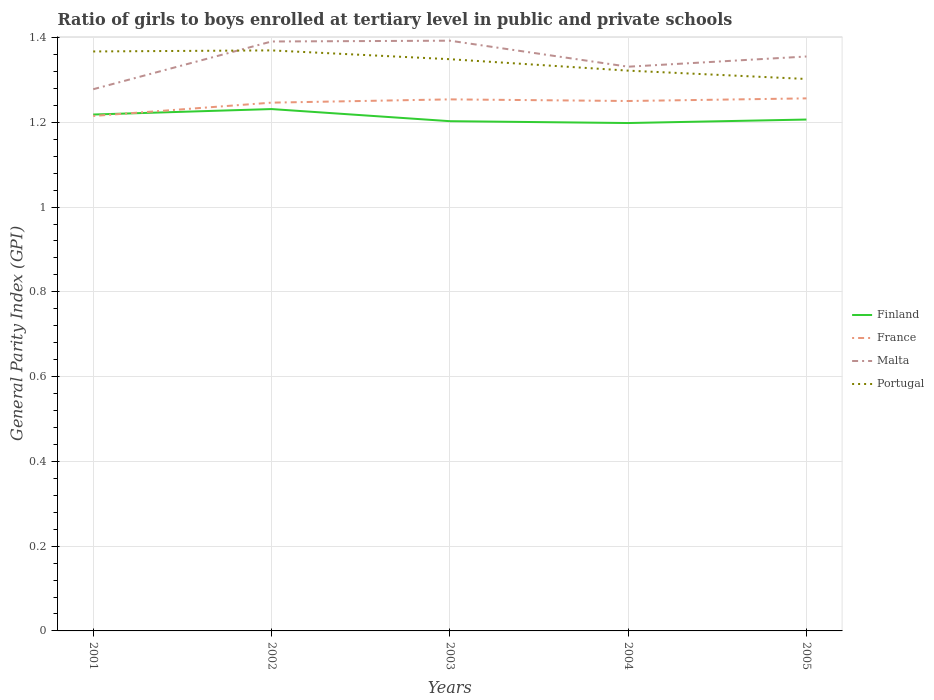Does the line corresponding to Finland intersect with the line corresponding to France?
Offer a terse response. Yes. Is the number of lines equal to the number of legend labels?
Offer a terse response. Yes. Across all years, what is the maximum general parity index in Malta?
Provide a short and direct response. 1.28. What is the total general parity index in Finland in the graph?
Offer a terse response. 0.01. What is the difference between the highest and the second highest general parity index in Portugal?
Ensure brevity in your answer.  0.07. Is the general parity index in France strictly greater than the general parity index in Finland over the years?
Offer a very short reply. No. What is the difference between two consecutive major ticks on the Y-axis?
Your answer should be very brief. 0.2. Are the values on the major ticks of Y-axis written in scientific E-notation?
Offer a very short reply. No. Does the graph contain any zero values?
Ensure brevity in your answer.  No. What is the title of the graph?
Your answer should be compact. Ratio of girls to boys enrolled at tertiary level in public and private schools. What is the label or title of the Y-axis?
Your answer should be compact. General Parity Index (GPI). What is the General Parity Index (GPI) in Finland in 2001?
Offer a terse response. 1.22. What is the General Parity Index (GPI) in France in 2001?
Give a very brief answer. 1.21. What is the General Parity Index (GPI) in Malta in 2001?
Provide a succinct answer. 1.28. What is the General Parity Index (GPI) in Portugal in 2001?
Offer a terse response. 1.37. What is the General Parity Index (GPI) of Finland in 2002?
Your answer should be compact. 1.23. What is the General Parity Index (GPI) of France in 2002?
Provide a short and direct response. 1.25. What is the General Parity Index (GPI) in Malta in 2002?
Offer a very short reply. 1.39. What is the General Parity Index (GPI) in Portugal in 2002?
Your answer should be compact. 1.37. What is the General Parity Index (GPI) of Finland in 2003?
Provide a short and direct response. 1.2. What is the General Parity Index (GPI) in France in 2003?
Make the answer very short. 1.25. What is the General Parity Index (GPI) in Malta in 2003?
Provide a short and direct response. 1.39. What is the General Parity Index (GPI) of Portugal in 2003?
Ensure brevity in your answer.  1.35. What is the General Parity Index (GPI) of Finland in 2004?
Provide a succinct answer. 1.2. What is the General Parity Index (GPI) of France in 2004?
Offer a terse response. 1.25. What is the General Parity Index (GPI) of Malta in 2004?
Provide a succinct answer. 1.33. What is the General Parity Index (GPI) in Portugal in 2004?
Offer a very short reply. 1.32. What is the General Parity Index (GPI) of Finland in 2005?
Offer a very short reply. 1.21. What is the General Parity Index (GPI) of France in 2005?
Ensure brevity in your answer.  1.26. What is the General Parity Index (GPI) of Malta in 2005?
Your answer should be very brief. 1.36. What is the General Parity Index (GPI) in Portugal in 2005?
Your answer should be very brief. 1.3. Across all years, what is the maximum General Parity Index (GPI) in Finland?
Ensure brevity in your answer.  1.23. Across all years, what is the maximum General Parity Index (GPI) in France?
Keep it short and to the point. 1.26. Across all years, what is the maximum General Parity Index (GPI) of Malta?
Give a very brief answer. 1.39. Across all years, what is the maximum General Parity Index (GPI) of Portugal?
Provide a succinct answer. 1.37. Across all years, what is the minimum General Parity Index (GPI) in Finland?
Your answer should be compact. 1.2. Across all years, what is the minimum General Parity Index (GPI) in France?
Your answer should be compact. 1.21. Across all years, what is the minimum General Parity Index (GPI) of Malta?
Make the answer very short. 1.28. Across all years, what is the minimum General Parity Index (GPI) in Portugal?
Your answer should be very brief. 1.3. What is the total General Parity Index (GPI) of Finland in the graph?
Keep it short and to the point. 6.06. What is the total General Parity Index (GPI) of France in the graph?
Provide a succinct answer. 6.22. What is the total General Parity Index (GPI) of Malta in the graph?
Give a very brief answer. 6.75. What is the total General Parity Index (GPI) in Portugal in the graph?
Your answer should be very brief. 6.71. What is the difference between the General Parity Index (GPI) in Finland in 2001 and that in 2002?
Offer a terse response. -0.01. What is the difference between the General Parity Index (GPI) in France in 2001 and that in 2002?
Provide a short and direct response. -0.03. What is the difference between the General Parity Index (GPI) of Malta in 2001 and that in 2002?
Make the answer very short. -0.11. What is the difference between the General Parity Index (GPI) in Portugal in 2001 and that in 2002?
Ensure brevity in your answer.  -0. What is the difference between the General Parity Index (GPI) of Finland in 2001 and that in 2003?
Your answer should be compact. 0.02. What is the difference between the General Parity Index (GPI) in France in 2001 and that in 2003?
Give a very brief answer. -0.04. What is the difference between the General Parity Index (GPI) of Malta in 2001 and that in 2003?
Make the answer very short. -0.11. What is the difference between the General Parity Index (GPI) in Portugal in 2001 and that in 2003?
Offer a terse response. 0.02. What is the difference between the General Parity Index (GPI) in Finland in 2001 and that in 2004?
Provide a short and direct response. 0.02. What is the difference between the General Parity Index (GPI) of France in 2001 and that in 2004?
Your answer should be very brief. -0.04. What is the difference between the General Parity Index (GPI) in Malta in 2001 and that in 2004?
Your answer should be very brief. -0.05. What is the difference between the General Parity Index (GPI) of Portugal in 2001 and that in 2004?
Make the answer very short. 0.05. What is the difference between the General Parity Index (GPI) of Finland in 2001 and that in 2005?
Your answer should be very brief. 0.01. What is the difference between the General Parity Index (GPI) of France in 2001 and that in 2005?
Offer a terse response. -0.04. What is the difference between the General Parity Index (GPI) of Malta in 2001 and that in 2005?
Your response must be concise. -0.08. What is the difference between the General Parity Index (GPI) in Portugal in 2001 and that in 2005?
Make the answer very short. 0.06. What is the difference between the General Parity Index (GPI) of Finland in 2002 and that in 2003?
Provide a short and direct response. 0.03. What is the difference between the General Parity Index (GPI) of France in 2002 and that in 2003?
Your answer should be very brief. -0.01. What is the difference between the General Parity Index (GPI) of Malta in 2002 and that in 2003?
Ensure brevity in your answer.  -0. What is the difference between the General Parity Index (GPI) in Portugal in 2002 and that in 2003?
Make the answer very short. 0.02. What is the difference between the General Parity Index (GPI) in Finland in 2002 and that in 2004?
Provide a short and direct response. 0.03. What is the difference between the General Parity Index (GPI) in France in 2002 and that in 2004?
Offer a very short reply. -0. What is the difference between the General Parity Index (GPI) of Malta in 2002 and that in 2004?
Provide a short and direct response. 0.06. What is the difference between the General Parity Index (GPI) in Portugal in 2002 and that in 2004?
Keep it short and to the point. 0.05. What is the difference between the General Parity Index (GPI) in Finland in 2002 and that in 2005?
Make the answer very short. 0.02. What is the difference between the General Parity Index (GPI) of France in 2002 and that in 2005?
Offer a terse response. -0.01. What is the difference between the General Parity Index (GPI) in Malta in 2002 and that in 2005?
Your answer should be very brief. 0.04. What is the difference between the General Parity Index (GPI) in Portugal in 2002 and that in 2005?
Ensure brevity in your answer.  0.07. What is the difference between the General Parity Index (GPI) in Finland in 2003 and that in 2004?
Give a very brief answer. 0. What is the difference between the General Parity Index (GPI) of France in 2003 and that in 2004?
Your answer should be very brief. 0. What is the difference between the General Parity Index (GPI) in Malta in 2003 and that in 2004?
Make the answer very short. 0.06. What is the difference between the General Parity Index (GPI) in Portugal in 2003 and that in 2004?
Provide a succinct answer. 0.03. What is the difference between the General Parity Index (GPI) of Finland in 2003 and that in 2005?
Your response must be concise. -0. What is the difference between the General Parity Index (GPI) in France in 2003 and that in 2005?
Offer a very short reply. -0. What is the difference between the General Parity Index (GPI) in Malta in 2003 and that in 2005?
Offer a terse response. 0.04. What is the difference between the General Parity Index (GPI) of Portugal in 2003 and that in 2005?
Provide a short and direct response. 0.05. What is the difference between the General Parity Index (GPI) of Finland in 2004 and that in 2005?
Your answer should be compact. -0.01. What is the difference between the General Parity Index (GPI) of France in 2004 and that in 2005?
Make the answer very short. -0.01. What is the difference between the General Parity Index (GPI) in Malta in 2004 and that in 2005?
Give a very brief answer. -0.02. What is the difference between the General Parity Index (GPI) in Portugal in 2004 and that in 2005?
Offer a very short reply. 0.02. What is the difference between the General Parity Index (GPI) of Finland in 2001 and the General Parity Index (GPI) of France in 2002?
Your answer should be very brief. -0.03. What is the difference between the General Parity Index (GPI) of Finland in 2001 and the General Parity Index (GPI) of Malta in 2002?
Offer a terse response. -0.17. What is the difference between the General Parity Index (GPI) in Finland in 2001 and the General Parity Index (GPI) in Portugal in 2002?
Your answer should be very brief. -0.15. What is the difference between the General Parity Index (GPI) of France in 2001 and the General Parity Index (GPI) of Malta in 2002?
Make the answer very short. -0.18. What is the difference between the General Parity Index (GPI) of France in 2001 and the General Parity Index (GPI) of Portugal in 2002?
Provide a short and direct response. -0.15. What is the difference between the General Parity Index (GPI) of Malta in 2001 and the General Parity Index (GPI) of Portugal in 2002?
Provide a succinct answer. -0.09. What is the difference between the General Parity Index (GPI) of Finland in 2001 and the General Parity Index (GPI) of France in 2003?
Provide a short and direct response. -0.04. What is the difference between the General Parity Index (GPI) of Finland in 2001 and the General Parity Index (GPI) of Malta in 2003?
Provide a short and direct response. -0.17. What is the difference between the General Parity Index (GPI) in Finland in 2001 and the General Parity Index (GPI) in Portugal in 2003?
Offer a terse response. -0.13. What is the difference between the General Parity Index (GPI) of France in 2001 and the General Parity Index (GPI) of Malta in 2003?
Your response must be concise. -0.18. What is the difference between the General Parity Index (GPI) in France in 2001 and the General Parity Index (GPI) in Portugal in 2003?
Give a very brief answer. -0.13. What is the difference between the General Parity Index (GPI) of Malta in 2001 and the General Parity Index (GPI) of Portugal in 2003?
Provide a succinct answer. -0.07. What is the difference between the General Parity Index (GPI) of Finland in 2001 and the General Parity Index (GPI) of France in 2004?
Your answer should be very brief. -0.03. What is the difference between the General Parity Index (GPI) of Finland in 2001 and the General Parity Index (GPI) of Malta in 2004?
Make the answer very short. -0.11. What is the difference between the General Parity Index (GPI) of Finland in 2001 and the General Parity Index (GPI) of Portugal in 2004?
Keep it short and to the point. -0.1. What is the difference between the General Parity Index (GPI) in France in 2001 and the General Parity Index (GPI) in Malta in 2004?
Provide a short and direct response. -0.12. What is the difference between the General Parity Index (GPI) in France in 2001 and the General Parity Index (GPI) in Portugal in 2004?
Your answer should be very brief. -0.11. What is the difference between the General Parity Index (GPI) in Malta in 2001 and the General Parity Index (GPI) in Portugal in 2004?
Offer a terse response. -0.04. What is the difference between the General Parity Index (GPI) in Finland in 2001 and the General Parity Index (GPI) in France in 2005?
Give a very brief answer. -0.04. What is the difference between the General Parity Index (GPI) in Finland in 2001 and the General Parity Index (GPI) in Malta in 2005?
Ensure brevity in your answer.  -0.14. What is the difference between the General Parity Index (GPI) in Finland in 2001 and the General Parity Index (GPI) in Portugal in 2005?
Keep it short and to the point. -0.08. What is the difference between the General Parity Index (GPI) of France in 2001 and the General Parity Index (GPI) of Malta in 2005?
Offer a very short reply. -0.14. What is the difference between the General Parity Index (GPI) in France in 2001 and the General Parity Index (GPI) in Portugal in 2005?
Provide a succinct answer. -0.09. What is the difference between the General Parity Index (GPI) of Malta in 2001 and the General Parity Index (GPI) of Portugal in 2005?
Offer a very short reply. -0.02. What is the difference between the General Parity Index (GPI) of Finland in 2002 and the General Parity Index (GPI) of France in 2003?
Provide a short and direct response. -0.02. What is the difference between the General Parity Index (GPI) in Finland in 2002 and the General Parity Index (GPI) in Malta in 2003?
Your answer should be very brief. -0.16. What is the difference between the General Parity Index (GPI) in Finland in 2002 and the General Parity Index (GPI) in Portugal in 2003?
Make the answer very short. -0.12. What is the difference between the General Parity Index (GPI) of France in 2002 and the General Parity Index (GPI) of Malta in 2003?
Provide a short and direct response. -0.15. What is the difference between the General Parity Index (GPI) of France in 2002 and the General Parity Index (GPI) of Portugal in 2003?
Make the answer very short. -0.1. What is the difference between the General Parity Index (GPI) of Malta in 2002 and the General Parity Index (GPI) of Portugal in 2003?
Your answer should be compact. 0.04. What is the difference between the General Parity Index (GPI) of Finland in 2002 and the General Parity Index (GPI) of France in 2004?
Give a very brief answer. -0.02. What is the difference between the General Parity Index (GPI) in Finland in 2002 and the General Parity Index (GPI) in Malta in 2004?
Keep it short and to the point. -0.1. What is the difference between the General Parity Index (GPI) of Finland in 2002 and the General Parity Index (GPI) of Portugal in 2004?
Provide a succinct answer. -0.09. What is the difference between the General Parity Index (GPI) in France in 2002 and the General Parity Index (GPI) in Malta in 2004?
Make the answer very short. -0.08. What is the difference between the General Parity Index (GPI) of France in 2002 and the General Parity Index (GPI) of Portugal in 2004?
Provide a short and direct response. -0.08. What is the difference between the General Parity Index (GPI) in Malta in 2002 and the General Parity Index (GPI) in Portugal in 2004?
Give a very brief answer. 0.07. What is the difference between the General Parity Index (GPI) in Finland in 2002 and the General Parity Index (GPI) in France in 2005?
Provide a succinct answer. -0.03. What is the difference between the General Parity Index (GPI) of Finland in 2002 and the General Parity Index (GPI) of Malta in 2005?
Give a very brief answer. -0.12. What is the difference between the General Parity Index (GPI) in Finland in 2002 and the General Parity Index (GPI) in Portugal in 2005?
Your answer should be compact. -0.07. What is the difference between the General Parity Index (GPI) of France in 2002 and the General Parity Index (GPI) of Malta in 2005?
Give a very brief answer. -0.11. What is the difference between the General Parity Index (GPI) of France in 2002 and the General Parity Index (GPI) of Portugal in 2005?
Your answer should be very brief. -0.06. What is the difference between the General Parity Index (GPI) of Malta in 2002 and the General Parity Index (GPI) of Portugal in 2005?
Ensure brevity in your answer.  0.09. What is the difference between the General Parity Index (GPI) of Finland in 2003 and the General Parity Index (GPI) of France in 2004?
Offer a very short reply. -0.05. What is the difference between the General Parity Index (GPI) of Finland in 2003 and the General Parity Index (GPI) of Malta in 2004?
Your answer should be very brief. -0.13. What is the difference between the General Parity Index (GPI) in Finland in 2003 and the General Parity Index (GPI) in Portugal in 2004?
Your answer should be very brief. -0.12. What is the difference between the General Parity Index (GPI) of France in 2003 and the General Parity Index (GPI) of Malta in 2004?
Offer a terse response. -0.08. What is the difference between the General Parity Index (GPI) in France in 2003 and the General Parity Index (GPI) in Portugal in 2004?
Make the answer very short. -0.07. What is the difference between the General Parity Index (GPI) in Malta in 2003 and the General Parity Index (GPI) in Portugal in 2004?
Provide a succinct answer. 0.07. What is the difference between the General Parity Index (GPI) of Finland in 2003 and the General Parity Index (GPI) of France in 2005?
Your answer should be compact. -0.05. What is the difference between the General Parity Index (GPI) in Finland in 2003 and the General Parity Index (GPI) in Malta in 2005?
Give a very brief answer. -0.15. What is the difference between the General Parity Index (GPI) of Finland in 2003 and the General Parity Index (GPI) of Portugal in 2005?
Make the answer very short. -0.1. What is the difference between the General Parity Index (GPI) of France in 2003 and the General Parity Index (GPI) of Malta in 2005?
Your answer should be very brief. -0.1. What is the difference between the General Parity Index (GPI) of France in 2003 and the General Parity Index (GPI) of Portugal in 2005?
Your answer should be compact. -0.05. What is the difference between the General Parity Index (GPI) of Malta in 2003 and the General Parity Index (GPI) of Portugal in 2005?
Provide a short and direct response. 0.09. What is the difference between the General Parity Index (GPI) in Finland in 2004 and the General Parity Index (GPI) in France in 2005?
Make the answer very short. -0.06. What is the difference between the General Parity Index (GPI) in Finland in 2004 and the General Parity Index (GPI) in Malta in 2005?
Offer a very short reply. -0.16. What is the difference between the General Parity Index (GPI) of Finland in 2004 and the General Parity Index (GPI) of Portugal in 2005?
Provide a short and direct response. -0.1. What is the difference between the General Parity Index (GPI) in France in 2004 and the General Parity Index (GPI) in Malta in 2005?
Your answer should be very brief. -0.1. What is the difference between the General Parity Index (GPI) of France in 2004 and the General Parity Index (GPI) of Portugal in 2005?
Your answer should be very brief. -0.05. What is the difference between the General Parity Index (GPI) of Malta in 2004 and the General Parity Index (GPI) of Portugal in 2005?
Your response must be concise. 0.03. What is the average General Parity Index (GPI) of Finland per year?
Make the answer very short. 1.21. What is the average General Parity Index (GPI) of France per year?
Your answer should be compact. 1.24. What is the average General Parity Index (GPI) in Malta per year?
Offer a very short reply. 1.35. What is the average General Parity Index (GPI) in Portugal per year?
Provide a short and direct response. 1.34. In the year 2001, what is the difference between the General Parity Index (GPI) of Finland and General Parity Index (GPI) of France?
Offer a very short reply. 0. In the year 2001, what is the difference between the General Parity Index (GPI) in Finland and General Parity Index (GPI) in Malta?
Keep it short and to the point. -0.06. In the year 2001, what is the difference between the General Parity Index (GPI) in Finland and General Parity Index (GPI) in Portugal?
Your answer should be compact. -0.15. In the year 2001, what is the difference between the General Parity Index (GPI) of France and General Parity Index (GPI) of Malta?
Provide a short and direct response. -0.06. In the year 2001, what is the difference between the General Parity Index (GPI) of France and General Parity Index (GPI) of Portugal?
Make the answer very short. -0.15. In the year 2001, what is the difference between the General Parity Index (GPI) of Malta and General Parity Index (GPI) of Portugal?
Provide a short and direct response. -0.09. In the year 2002, what is the difference between the General Parity Index (GPI) of Finland and General Parity Index (GPI) of France?
Your answer should be very brief. -0.02. In the year 2002, what is the difference between the General Parity Index (GPI) in Finland and General Parity Index (GPI) in Malta?
Provide a succinct answer. -0.16. In the year 2002, what is the difference between the General Parity Index (GPI) in Finland and General Parity Index (GPI) in Portugal?
Your answer should be very brief. -0.14. In the year 2002, what is the difference between the General Parity Index (GPI) of France and General Parity Index (GPI) of Malta?
Provide a succinct answer. -0.14. In the year 2002, what is the difference between the General Parity Index (GPI) in France and General Parity Index (GPI) in Portugal?
Make the answer very short. -0.12. In the year 2002, what is the difference between the General Parity Index (GPI) in Malta and General Parity Index (GPI) in Portugal?
Make the answer very short. 0.02. In the year 2003, what is the difference between the General Parity Index (GPI) in Finland and General Parity Index (GPI) in France?
Provide a short and direct response. -0.05. In the year 2003, what is the difference between the General Parity Index (GPI) of Finland and General Parity Index (GPI) of Malta?
Provide a succinct answer. -0.19. In the year 2003, what is the difference between the General Parity Index (GPI) of Finland and General Parity Index (GPI) of Portugal?
Your answer should be compact. -0.15. In the year 2003, what is the difference between the General Parity Index (GPI) of France and General Parity Index (GPI) of Malta?
Provide a short and direct response. -0.14. In the year 2003, what is the difference between the General Parity Index (GPI) of France and General Parity Index (GPI) of Portugal?
Provide a succinct answer. -0.09. In the year 2003, what is the difference between the General Parity Index (GPI) in Malta and General Parity Index (GPI) in Portugal?
Offer a very short reply. 0.04. In the year 2004, what is the difference between the General Parity Index (GPI) of Finland and General Parity Index (GPI) of France?
Your response must be concise. -0.05. In the year 2004, what is the difference between the General Parity Index (GPI) in Finland and General Parity Index (GPI) in Malta?
Give a very brief answer. -0.13. In the year 2004, what is the difference between the General Parity Index (GPI) in Finland and General Parity Index (GPI) in Portugal?
Your answer should be very brief. -0.12. In the year 2004, what is the difference between the General Parity Index (GPI) of France and General Parity Index (GPI) of Malta?
Your answer should be very brief. -0.08. In the year 2004, what is the difference between the General Parity Index (GPI) in France and General Parity Index (GPI) in Portugal?
Offer a terse response. -0.07. In the year 2004, what is the difference between the General Parity Index (GPI) of Malta and General Parity Index (GPI) of Portugal?
Give a very brief answer. 0.01. In the year 2005, what is the difference between the General Parity Index (GPI) of Finland and General Parity Index (GPI) of Malta?
Ensure brevity in your answer.  -0.15. In the year 2005, what is the difference between the General Parity Index (GPI) of Finland and General Parity Index (GPI) of Portugal?
Offer a very short reply. -0.1. In the year 2005, what is the difference between the General Parity Index (GPI) of France and General Parity Index (GPI) of Malta?
Keep it short and to the point. -0.1. In the year 2005, what is the difference between the General Parity Index (GPI) in France and General Parity Index (GPI) in Portugal?
Ensure brevity in your answer.  -0.05. In the year 2005, what is the difference between the General Parity Index (GPI) of Malta and General Parity Index (GPI) of Portugal?
Your response must be concise. 0.05. What is the ratio of the General Parity Index (GPI) of France in 2001 to that in 2002?
Your response must be concise. 0.97. What is the ratio of the General Parity Index (GPI) of Malta in 2001 to that in 2002?
Provide a succinct answer. 0.92. What is the ratio of the General Parity Index (GPI) in France in 2001 to that in 2003?
Your answer should be compact. 0.97. What is the ratio of the General Parity Index (GPI) of Malta in 2001 to that in 2003?
Ensure brevity in your answer.  0.92. What is the ratio of the General Parity Index (GPI) in Portugal in 2001 to that in 2003?
Offer a very short reply. 1.01. What is the ratio of the General Parity Index (GPI) of Finland in 2001 to that in 2004?
Give a very brief answer. 1.02. What is the ratio of the General Parity Index (GPI) in France in 2001 to that in 2004?
Keep it short and to the point. 0.97. What is the ratio of the General Parity Index (GPI) in Malta in 2001 to that in 2004?
Your answer should be very brief. 0.96. What is the ratio of the General Parity Index (GPI) of Portugal in 2001 to that in 2004?
Offer a terse response. 1.03. What is the ratio of the General Parity Index (GPI) of Finland in 2001 to that in 2005?
Make the answer very short. 1.01. What is the ratio of the General Parity Index (GPI) in France in 2001 to that in 2005?
Offer a very short reply. 0.97. What is the ratio of the General Parity Index (GPI) of Malta in 2001 to that in 2005?
Provide a short and direct response. 0.94. What is the ratio of the General Parity Index (GPI) in Portugal in 2001 to that in 2005?
Your answer should be very brief. 1.05. What is the ratio of the General Parity Index (GPI) of Finland in 2002 to that in 2003?
Your answer should be compact. 1.02. What is the ratio of the General Parity Index (GPI) in Malta in 2002 to that in 2003?
Your response must be concise. 1. What is the ratio of the General Parity Index (GPI) in Portugal in 2002 to that in 2003?
Make the answer very short. 1.02. What is the ratio of the General Parity Index (GPI) in Finland in 2002 to that in 2004?
Offer a terse response. 1.03. What is the ratio of the General Parity Index (GPI) of Malta in 2002 to that in 2004?
Provide a succinct answer. 1.04. What is the ratio of the General Parity Index (GPI) of Portugal in 2002 to that in 2004?
Your answer should be compact. 1.04. What is the ratio of the General Parity Index (GPI) of Finland in 2002 to that in 2005?
Provide a succinct answer. 1.02. What is the ratio of the General Parity Index (GPI) in France in 2002 to that in 2005?
Your answer should be compact. 0.99. What is the ratio of the General Parity Index (GPI) in Malta in 2002 to that in 2005?
Make the answer very short. 1.03. What is the ratio of the General Parity Index (GPI) in Portugal in 2002 to that in 2005?
Give a very brief answer. 1.05. What is the ratio of the General Parity Index (GPI) in France in 2003 to that in 2004?
Make the answer very short. 1. What is the ratio of the General Parity Index (GPI) of Malta in 2003 to that in 2004?
Keep it short and to the point. 1.05. What is the ratio of the General Parity Index (GPI) of Portugal in 2003 to that in 2004?
Offer a very short reply. 1.02. What is the ratio of the General Parity Index (GPI) in Finland in 2003 to that in 2005?
Provide a succinct answer. 1. What is the ratio of the General Parity Index (GPI) in Malta in 2003 to that in 2005?
Keep it short and to the point. 1.03. What is the ratio of the General Parity Index (GPI) in Portugal in 2003 to that in 2005?
Your answer should be compact. 1.04. What is the ratio of the General Parity Index (GPI) in Finland in 2004 to that in 2005?
Provide a short and direct response. 0.99. What is the ratio of the General Parity Index (GPI) in Malta in 2004 to that in 2005?
Ensure brevity in your answer.  0.98. What is the ratio of the General Parity Index (GPI) in Portugal in 2004 to that in 2005?
Provide a succinct answer. 1.02. What is the difference between the highest and the second highest General Parity Index (GPI) of Finland?
Keep it short and to the point. 0.01. What is the difference between the highest and the second highest General Parity Index (GPI) of France?
Your answer should be very brief. 0. What is the difference between the highest and the second highest General Parity Index (GPI) in Malta?
Provide a succinct answer. 0. What is the difference between the highest and the second highest General Parity Index (GPI) in Portugal?
Give a very brief answer. 0. What is the difference between the highest and the lowest General Parity Index (GPI) of Finland?
Give a very brief answer. 0.03. What is the difference between the highest and the lowest General Parity Index (GPI) of France?
Provide a succinct answer. 0.04. What is the difference between the highest and the lowest General Parity Index (GPI) of Malta?
Your answer should be very brief. 0.11. What is the difference between the highest and the lowest General Parity Index (GPI) in Portugal?
Make the answer very short. 0.07. 